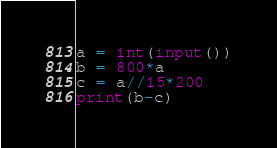<code> <loc_0><loc_0><loc_500><loc_500><_Python_>a = int(input())
b = 800*a
c = a//15*200
print(b-c)</code> 